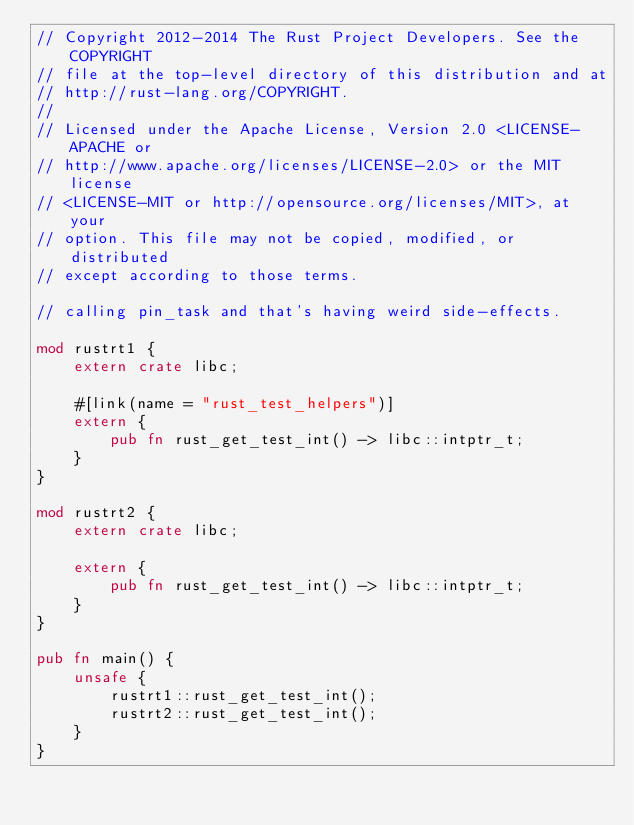Convert code to text. <code><loc_0><loc_0><loc_500><loc_500><_Rust_>// Copyright 2012-2014 The Rust Project Developers. See the COPYRIGHT
// file at the top-level directory of this distribution and at
// http://rust-lang.org/COPYRIGHT.
//
// Licensed under the Apache License, Version 2.0 <LICENSE-APACHE or
// http://www.apache.org/licenses/LICENSE-2.0> or the MIT license
// <LICENSE-MIT or http://opensource.org/licenses/MIT>, at your
// option. This file may not be copied, modified, or distributed
// except according to those terms.

// calling pin_task and that's having weird side-effects.

mod rustrt1 {
    extern crate libc;

    #[link(name = "rust_test_helpers")]
    extern {
        pub fn rust_get_test_int() -> libc::intptr_t;
    }
}

mod rustrt2 {
    extern crate libc;

    extern {
        pub fn rust_get_test_int() -> libc::intptr_t;
    }
}

pub fn main() {
    unsafe {
        rustrt1::rust_get_test_int();
        rustrt2::rust_get_test_int();
    }
}
</code> 